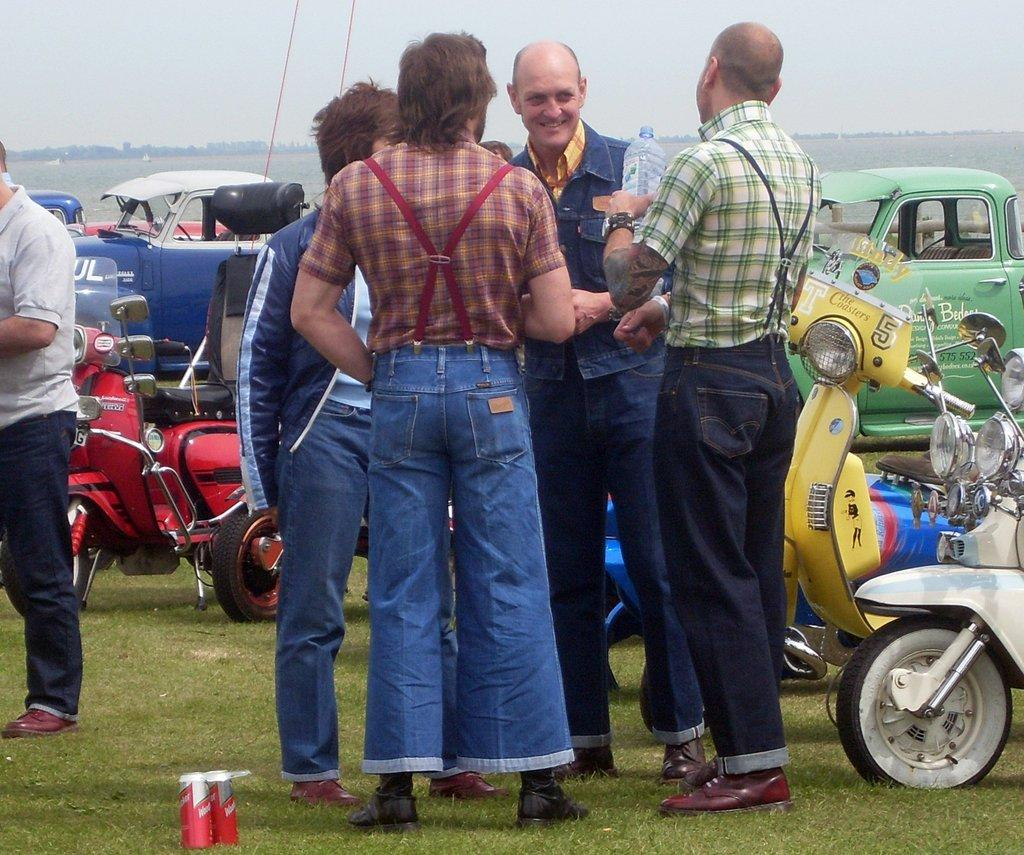What is the main subject of the image? The main subject of the image is a group of persons standing in the center. Where are the persons standing? The group of persons is standing on the grass. What can be seen in the background of the image? There are vehicles and scooters in the background, as well as grass and the sky. What type of muscle is visible on the scooters in the image? There are no muscles visible in the image, as the image features a group of persons standing on the grass and vehicles and scooters in the background. --- Facts: 1. There is a person holding a camera in the image. 2. The person is standing on a bridge. 3. There is a river visible in the image. 4. The sky is visible in the image. 5. There are trees in the background of the image. Absurd Topics: fish, bicycle, sand Conversation: What is the person in the image holding? The person in the image is holding a camera. Where is the person standing? The person is standing on a bridge. What can be seen below the bridge in the image? There is a river visible in the image. What is visible elements are present in the sky? The sky is visible in the image. What type of vegetation can be seen in the background? There are trees in the background of the image. Reasoning: Let's think step by step in order to produce the conversation. We start by identifying the main subject of the image, which is the person holding a camera. Then, we describe their location, which is on a bridge. Next, we expand the conversation to include the river, sky, and trees visible in the image. Each question is designed to elicit a specific detail about the image that is known from the provided facts. Absurd Question/Answer: How many bicycles are visible in the sand in the image? There are no bicycles or sand present in the image. 